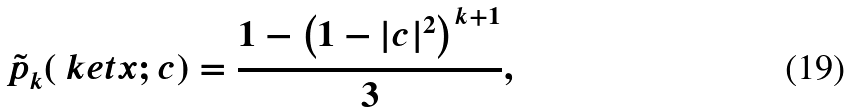Convert formula to latex. <formula><loc_0><loc_0><loc_500><loc_500>\tilde { p } _ { k } ( \ k e t { x } ; c ) = \frac { 1 - \left ( 1 - | c | ^ { 2 } \right ) ^ { k + 1 } } { 3 } ,</formula> 